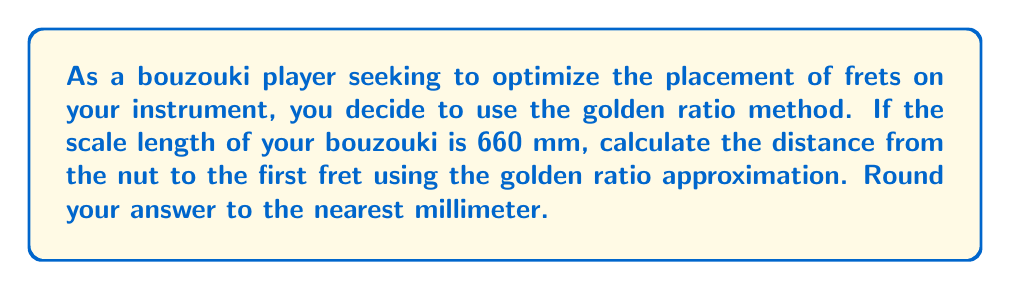Provide a solution to this math problem. To optimize the placement of frets on a bouzouki neck using the golden ratio method, we follow these steps:

1) The golden ratio, denoted by φ (phi), is approximately 1.618033988749895.

2) In the context of fret placement, we use the reciprocal of the golden ratio: 
   $$\frac{1}{\phi} \approx 0.618033988749895$$

3) To find the distance from the nut to the first fret, we multiply the scale length by this value:

   $$\text{First fret distance} = \text{Scale length} \times \frac{1}{\phi}$$

4) Given the scale length of 660 mm, we calculate:

   $$\text{First fret distance} = 660 \times 0.618033988749895$$

5) Performing this calculation:

   $$\text{First fret distance} = 407.9024325549305 \text{ mm}$$

6) Rounding to the nearest millimeter:

   $$\text{First fret distance} \approx 408 \text{ mm}$$

This method provides a good approximation for fret placement, though more precise calculations (such as the "Rule of 18" or computer-aided optimization) might be used for professional instrument making.
Answer: 408 mm 